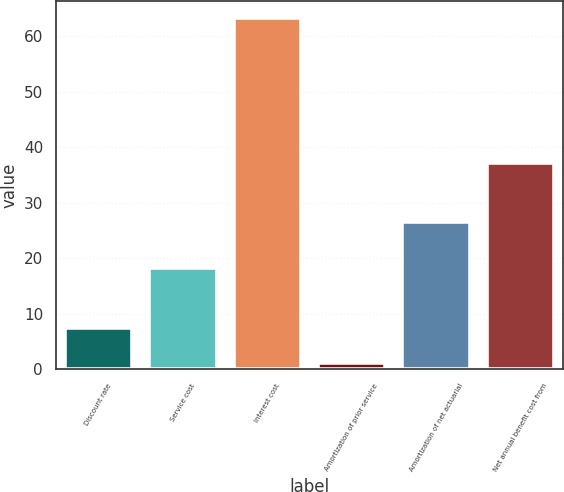<chart> <loc_0><loc_0><loc_500><loc_500><bar_chart><fcel>Discount rate<fcel>Service cost<fcel>Interest cost<fcel>Amortization of prior service<fcel>Amortization of net actuarial<fcel>Net annual benefit cost from<nl><fcel>7.4<fcel>18.2<fcel>63.2<fcel>1.2<fcel>26.5<fcel>37.2<nl></chart> 